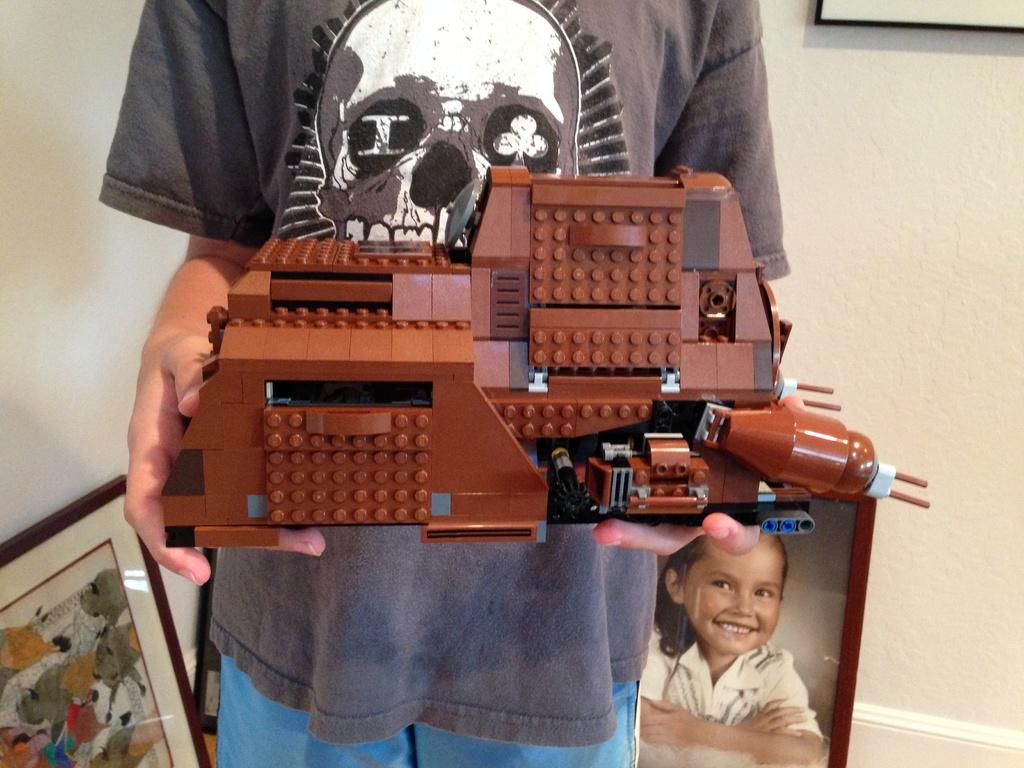Who or what is the main subject in the image? There is a person in the image. What is the person holding in the image? The person is holding a toy made with blocks. What can be seen in the background of the image? There is a wall in the background of the image. Are there any other objects or decorations visible in the image? Yes, there are photo frames in the image. What type of sail can be seen in the image? There is no sail present in the image. Is there a cable attached to the toy made with blocks? The image does not show any cables attached to the toy made with blocks. 